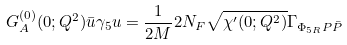<formula> <loc_0><loc_0><loc_500><loc_500>G _ { A } ^ { ( 0 ) } ( 0 ; Q ^ { 2 } ) \bar { u } \gamma _ { 5 } u = { \frac { 1 } { 2 M } } 2 N _ { F } \sqrt { \chi ^ { \prime } ( 0 ; Q ^ { 2 } ) } \Gamma _ { \Phi _ { 5 R } P \bar { P } }</formula> 